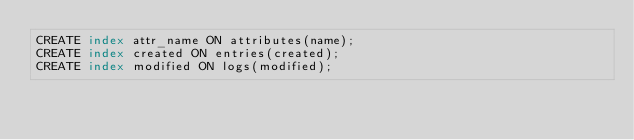<code> <loc_0><loc_0><loc_500><loc_500><_SQL_>CREATE index attr_name ON attributes(name);
CREATE index created ON entries(created);
CREATE index modified ON logs(modified);</code> 